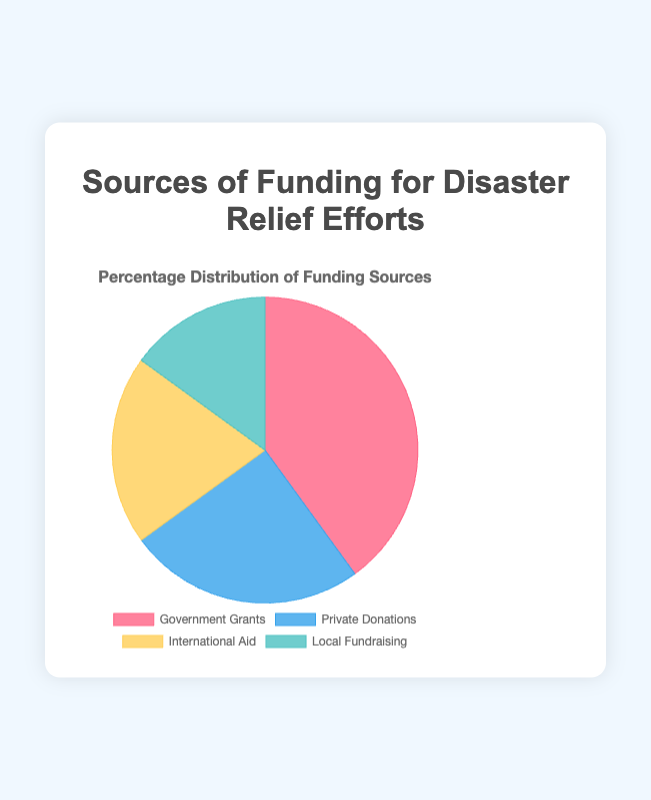What is the largest source of funding for disaster relief efforts? The figure shows that Government Grants account for the largest share of funding at 40%. This is the segment with the largest percentage in the pie chart.
Answer: Government Grants Which source provides the smallest percentage of disaster relief funding? According to the figure, Local Fundraising constitutes the smallest portion of the funding sources, accounting for 15%. This is the smallest segment in the pie chart.
Answer: Local Fundraising By how much does Government Grants exceed Private Donations in disaster relief funding? Government Grants account for 40% of the funding, while Private Donations make up 25%. The difference is 40% - 25% = 15%.
Answer: 15% What is the total percentage of funding contributed by Private Donations and International Aid? Private Donations contribute 25% and International Aid contributes 20%. Adding these gives 25% + 20% = 45%.
Answer: 45% What percentage of funding is contributed by non-Government sources? The non-Government sources are Private Donations (25%), International Aid (20%), and Local Fundraising (15%). Adding these gives 25% + 20% + 15% = 60%.
Answer: 60% Which funding source is represented by the blue segment in the pie chart? The blue-colored segment corresponds to Private Donations in the pie chart.
Answer: Private Donations How does the percentage contribution of International Aid compare to that of Local Fundraising? International Aid contributes 20%, while Local Fundraising provides 15%. As 20% is greater than 15%, International Aid has a higher percentage.
Answer: International Aid > Local Fundraising What is the combined percentage of Government Grants and Local Fundraising? Government Grants contribute 40%, and Local Fundraising contributes 15%. The combined percentage is 40% + 15% = 55%.
Answer: 55% If Government Grants were reduced by 10%, what would be the new percentage, and would it still be the largest source? Reducing Government Grants by 10% changes its contribution from 40% to 40% - 10% = 30%. Private Donations would then become the largest source, as 30% is still less than 25%.
Answer: 30%, No What's the difference between the highest and lowest funding sources in percentage points? The highest funding source is Government Grants at 40%, and the lowest is Local Fundraising at 15%. The difference is 40% - 15% = 25%.
Answer: 25% 